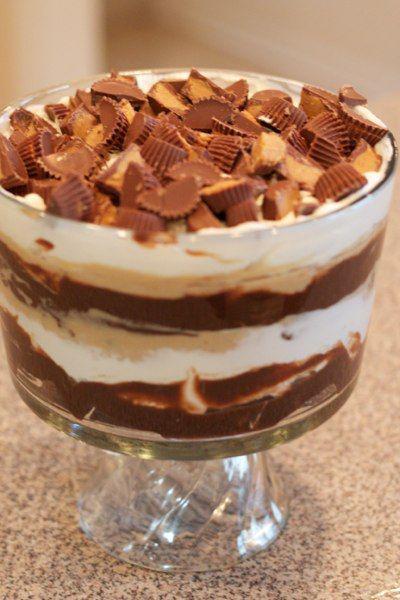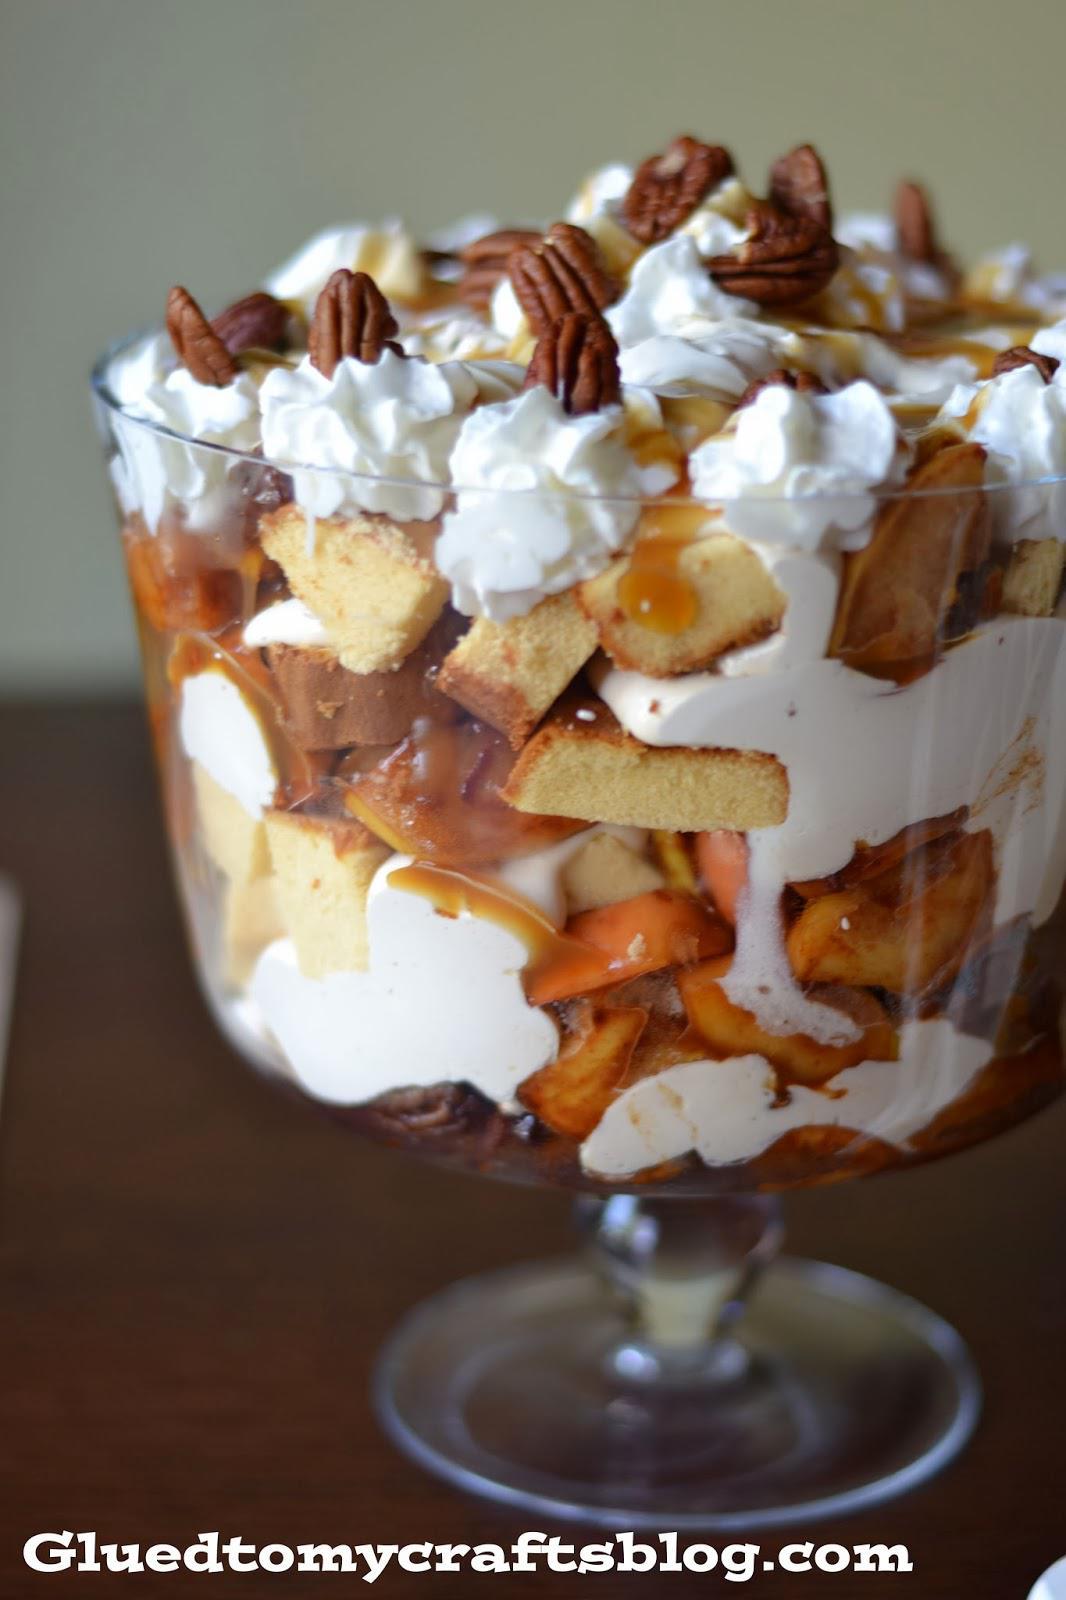The first image is the image on the left, the second image is the image on the right. Given the left and right images, does the statement "Some of the desserts are dished out in individual servings." hold true? Answer yes or no. No. The first image is the image on the left, the second image is the image on the right. Analyze the images presented: Is the assertion "No more than one dessert is shown on each picture." valid? Answer yes or no. Yes. 